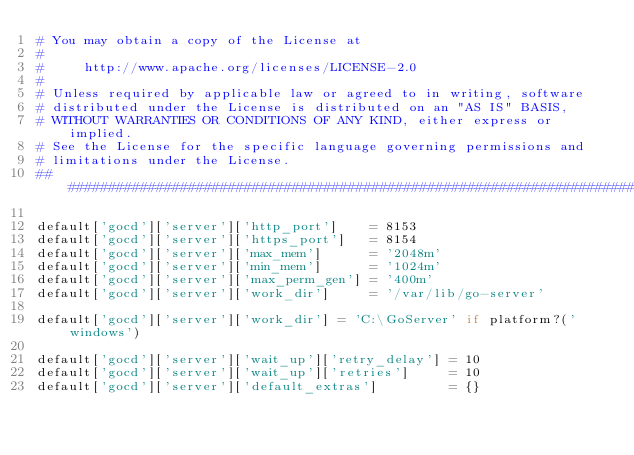Convert code to text. <code><loc_0><loc_0><loc_500><loc_500><_Ruby_># You may obtain a copy of the License at
#
#     http://www.apache.org/licenses/LICENSE-2.0
#
# Unless required by applicable law or agreed to in writing, software
# distributed under the License is distributed on an "AS IS" BASIS,
# WITHOUT WARRANTIES OR CONDITIONS OF ANY KIND, either express or implied.
# See the License for the specific language governing permissions and
# limitations under the License.
##########################################################################

default['gocd']['server']['http_port']    = 8153
default['gocd']['server']['https_port']   = 8154
default['gocd']['server']['max_mem']      = '2048m'
default['gocd']['server']['min_mem']      = '1024m'
default['gocd']['server']['max_perm_gen'] = '400m'
default['gocd']['server']['work_dir']     = '/var/lib/go-server'

default['gocd']['server']['work_dir'] = 'C:\GoServer' if platform?('windows')

default['gocd']['server']['wait_up']['retry_delay'] = 10
default['gocd']['server']['wait_up']['retries']     = 10
default['gocd']['server']['default_extras']         = {}
</code> 